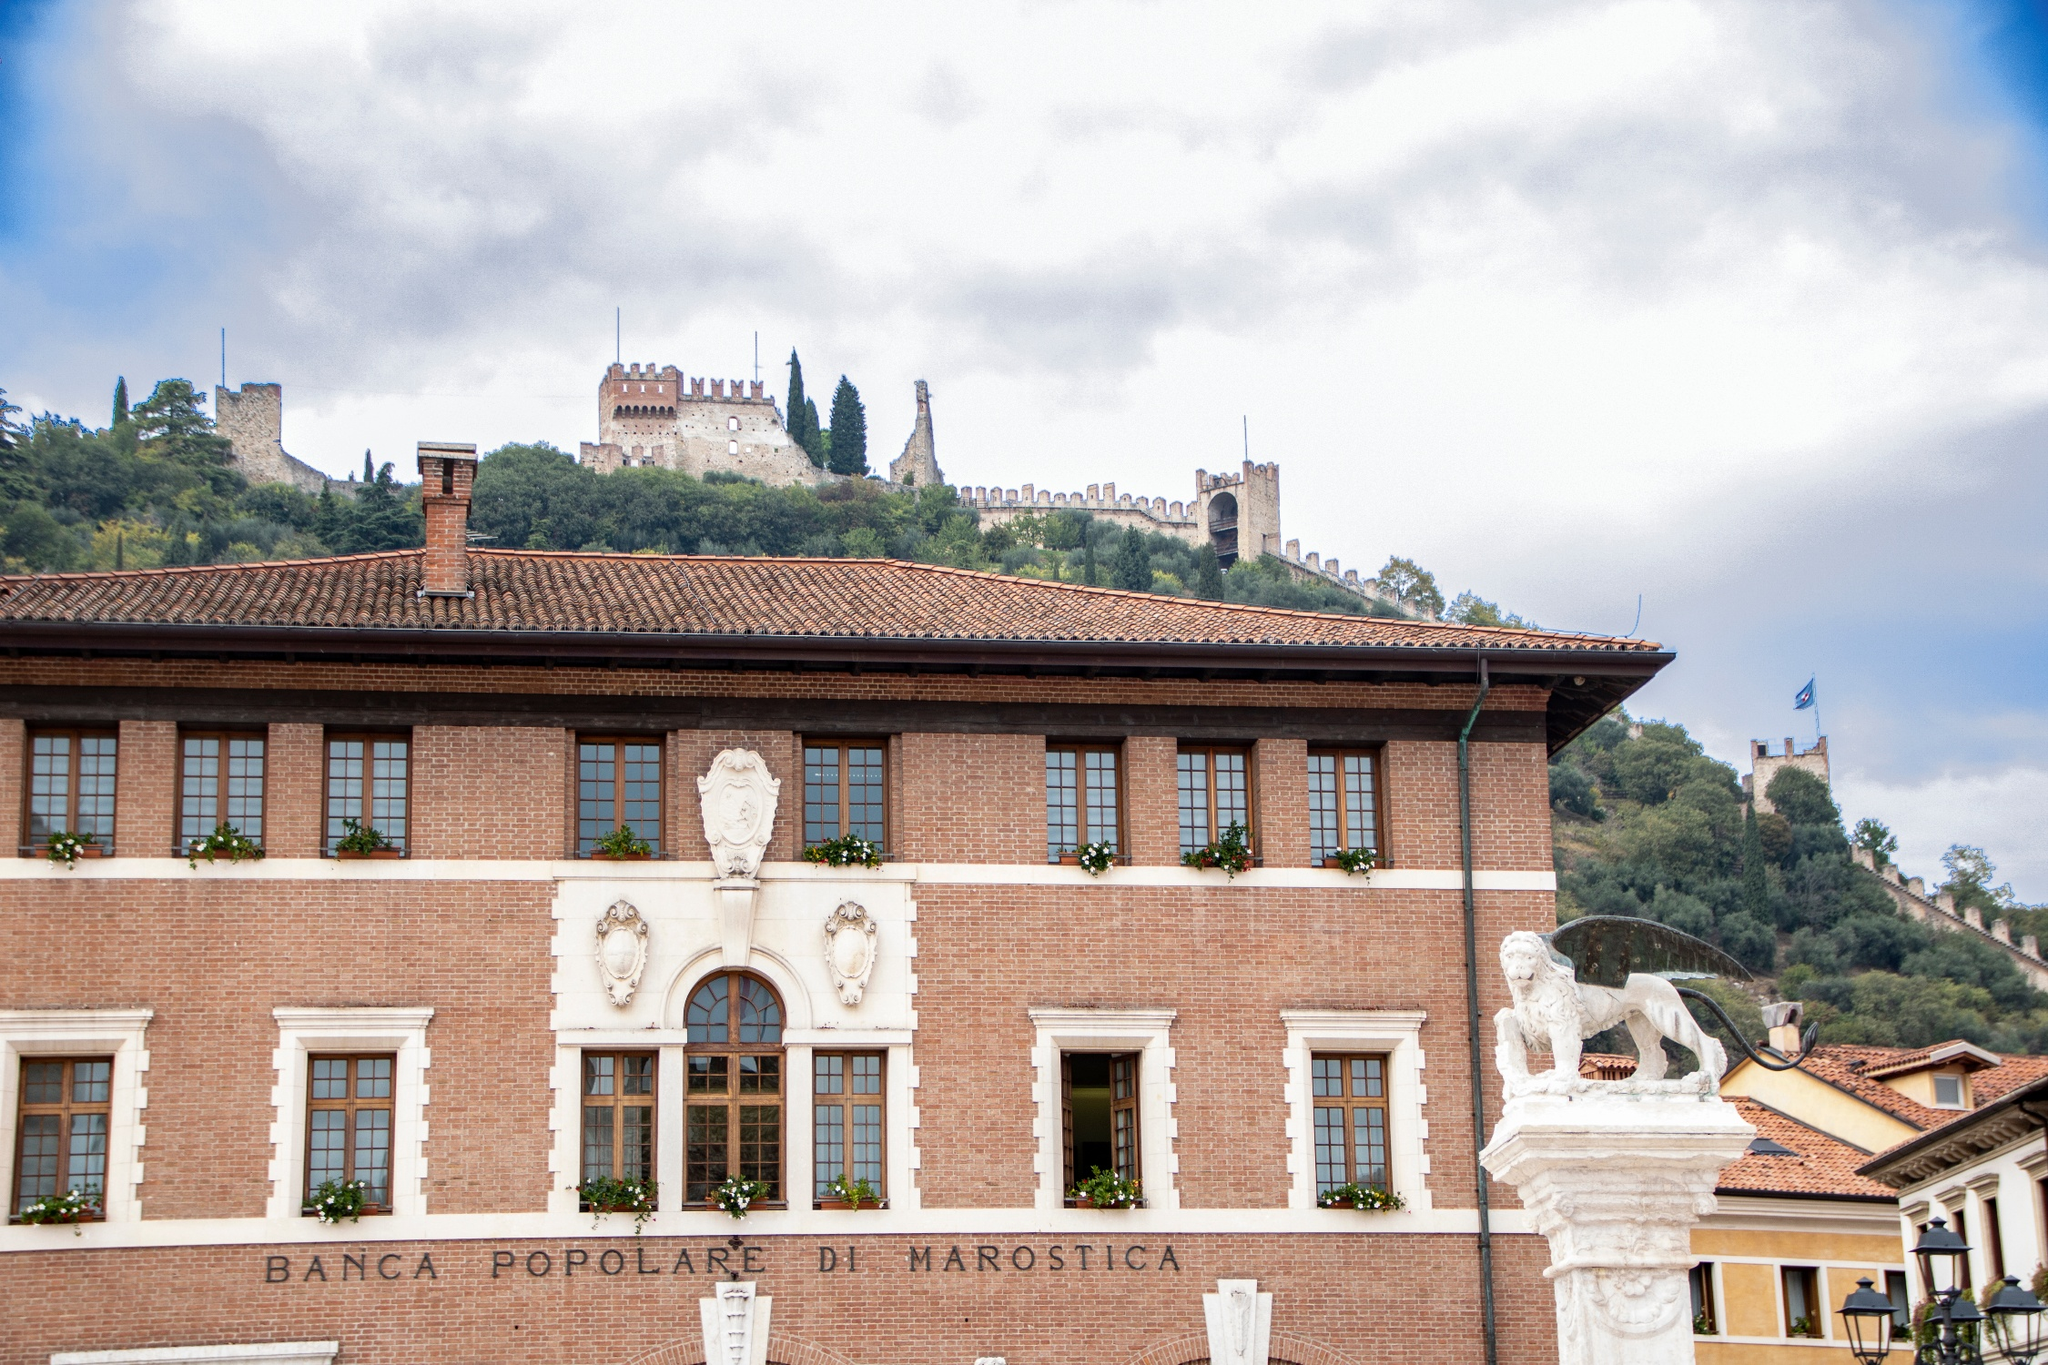Imagine a fictional story set in the scene depicted in the image. Beneath the watchful eye of the Castello di Marostica, an annual festival filled the square with vibrant life. Townsfolk gathered around the Banca Popolare di Marostica, where legend spoke of a hidden treasure buried beneath its foundations. According to the tale, during a siege centuries ago, the castle's defenders had buried their riches to safeguard them from invaders.

Amanda, a young archaeologist with a passion for uncovering Marostica's secrets, stood by the lion statue, her heart racing with excitement. She had discovered an old map in the castle archives that hinted at the treasure's location. As clouds gently swirled in the blue sky above, she knew this festival was the perfect cover for her clandestine excavation.

With dusk approaching, Amanda and her trusted friend Marco, a local historian, discreetly started digging near the lion statue. The festival's noise masked their work, and soon their shovels struck something hard. Pulling away the dirt, they unearthed an ancient chest covered in intricate carvings. The crowd unknowingly cheered for their festivities as Amanda opened the chest to reveal not gold or jewels, but a collection of ancient manuscripts. These papers detailed Marostica's history, written by its earliest inhabitants, providing insights into centuries of stories, battles, and heritage.

Amanda and Marco realized the true treasure wasn't material wealth but the untold tales of Marostica. The manuscripts were preserved and put on display, attracting historians and tourists alike, embedding the town deeper into the annals of history. 